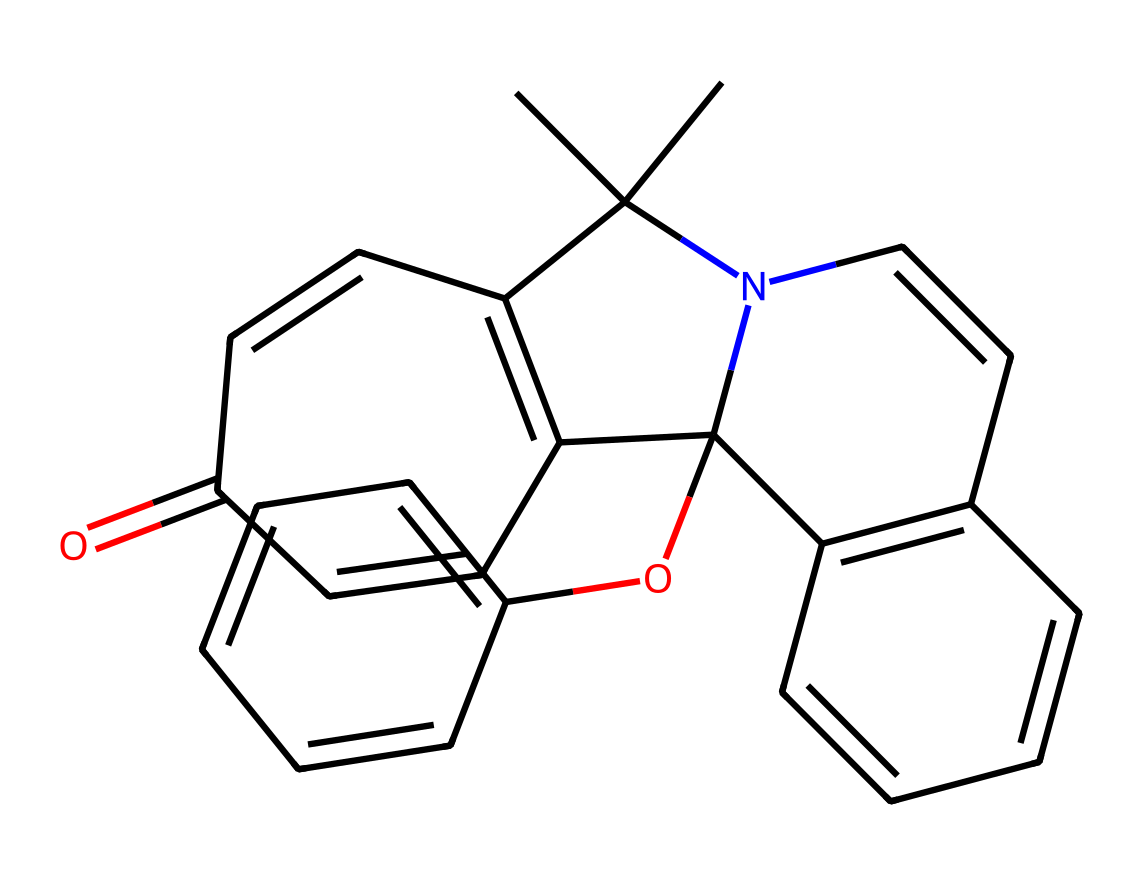What is the chemical name of the compound represented by this SMILES? The SMILES provided corresponds to a compound known as spiropyran, commonly used in color-changing lenses. The structure reveals distinctive features of spiropyran, such as the fused ring systems indicative of this chemical class.
Answer: spiropyran How many carbon atoms are present in the chemical structure? In the provided SMILES, by counting the carbon atoms (C) in various parts of the structure, there are 20 carbon atoms in total. The resonance and cyclic nature of the structure showcases multiple carbon arrangements.
Answer: 20 What type of bonding is primarily observed in this chemical structure? The structure shows several double bonds (indicated by '=' in the SMILES), suggesting that the primary type of bonding present is covalent bonding. The multiple ring systems also indicate aromatic character, which is a type of covalent bonding.
Answer: covalent What is the role of this compound in color-changing lenses? Spiropyran acts as a photoreactive compound that changes color upon exposure to UV light. This property stems from its ability to undergo a reversible transformation induced by light, providing the mechanism for color change in specific applications like eyewear or optical devices.
Answer: photoreactive What unique feature allows spiropyran to change color? The unique feature that enables spiropyran to change color is its ability to undergo photoisomerization. When exposed to UV light, the molecular structure rearranges, leading to a different color appearance due to changes in the electronic properties of the compound.
Answer: photoisomerization How many nitrogen atoms are in the chemical structure? By inspecting the SMILES code, we can identify a single nitrogen atom (N) in the structure, which typically contributes to the overall reactivity and properties of spiropyran compounds.
Answer: 1 